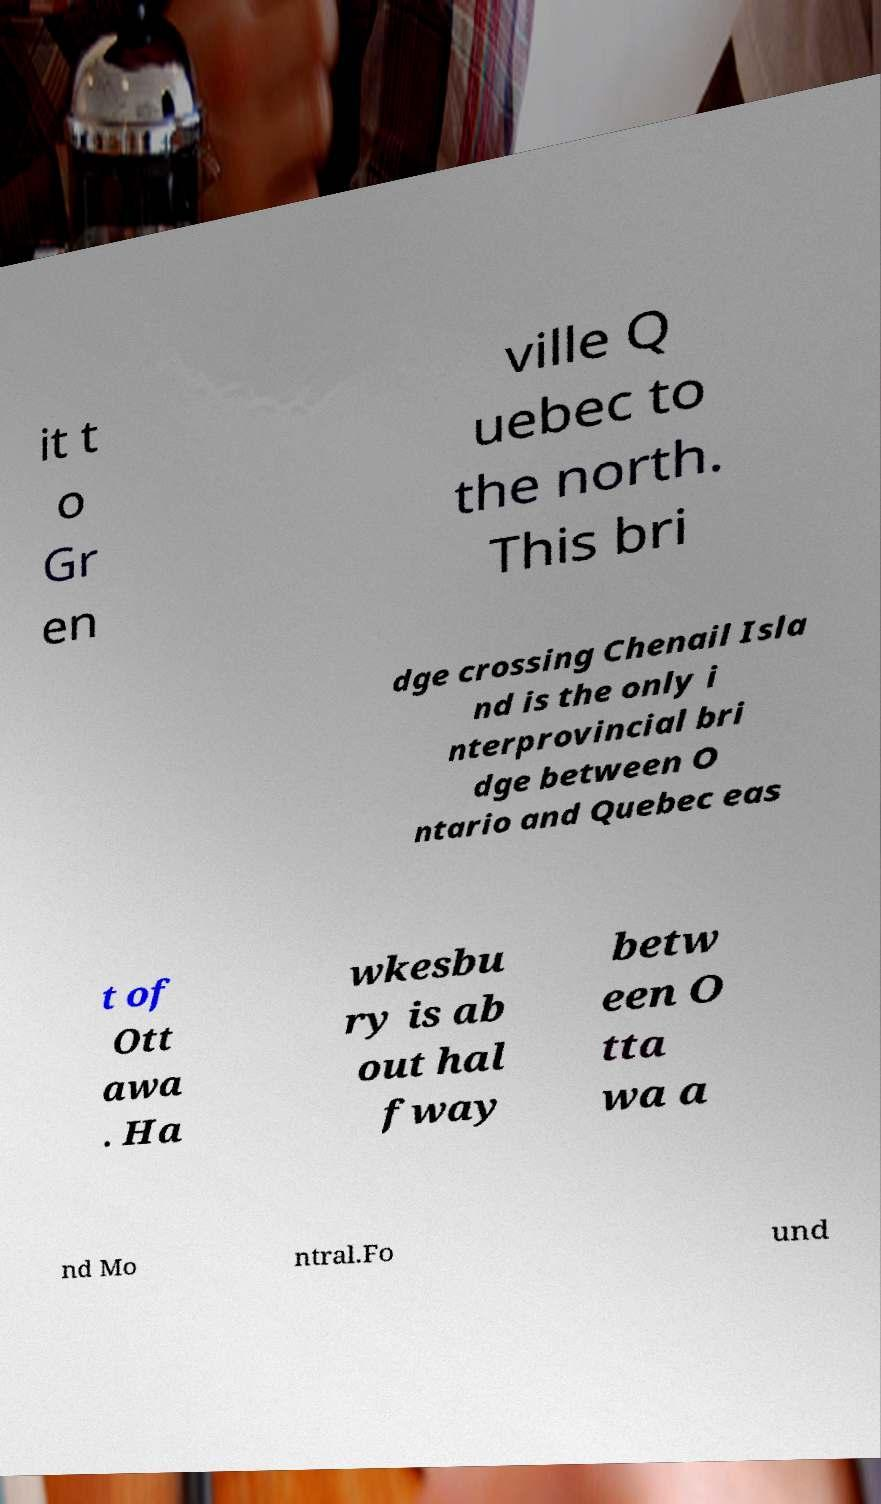Please identify and transcribe the text found in this image. it t o Gr en ville Q uebec to the north. This bri dge crossing Chenail Isla nd is the only i nterprovincial bri dge between O ntario and Quebec eas t of Ott awa . Ha wkesbu ry is ab out hal fway betw een O tta wa a nd Mo ntral.Fo und 